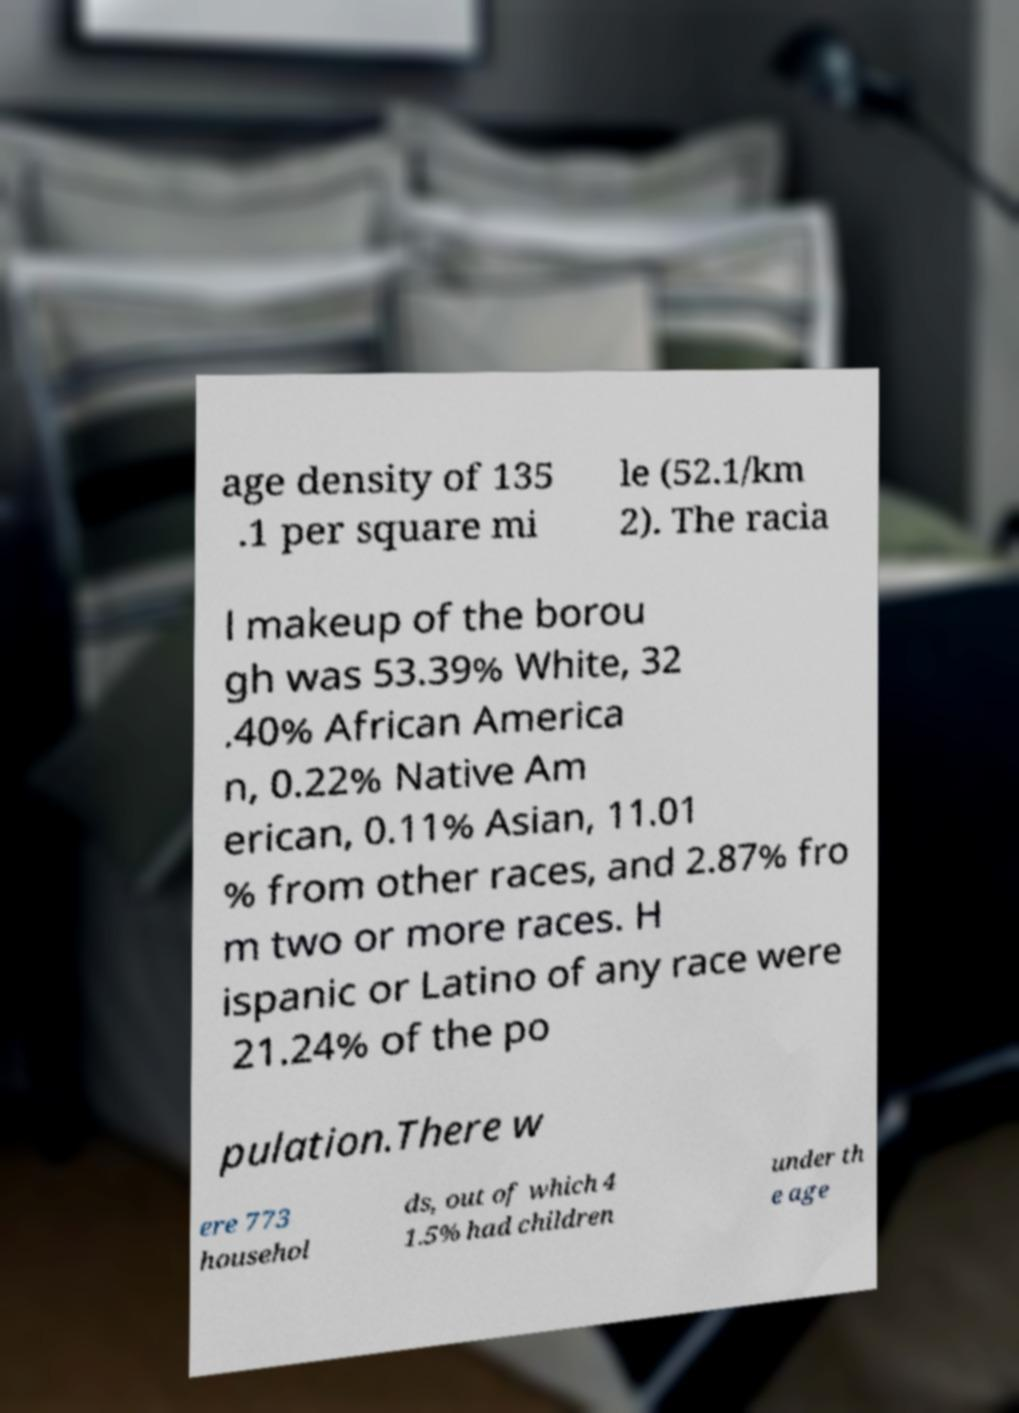For documentation purposes, I need the text within this image transcribed. Could you provide that? age density of 135 .1 per square mi le (52.1/km 2). The racia l makeup of the borou gh was 53.39% White, 32 .40% African America n, 0.22% Native Am erican, 0.11% Asian, 11.01 % from other races, and 2.87% fro m two or more races. H ispanic or Latino of any race were 21.24% of the po pulation.There w ere 773 househol ds, out of which 4 1.5% had children under th e age 